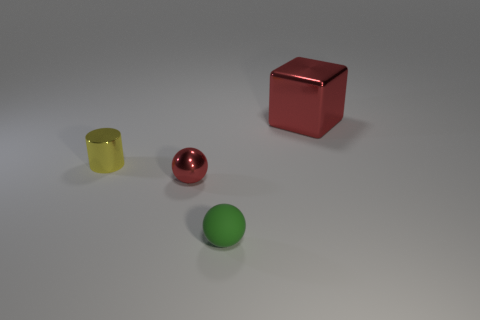Add 2 small yellow metallic cylinders. How many objects exist? 6 Subtract all cylinders. How many objects are left? 3 Subtract all purple metal cylinders. Subtract all metallic cylinders. How many objects are left? 3 Add 1 small metallic cylinders. How many small metallic cylinders are left? 2 Add 3 blocks. How many blocks exist? 4 Subtract 0 blue cylinders. How many objects are left? 4 